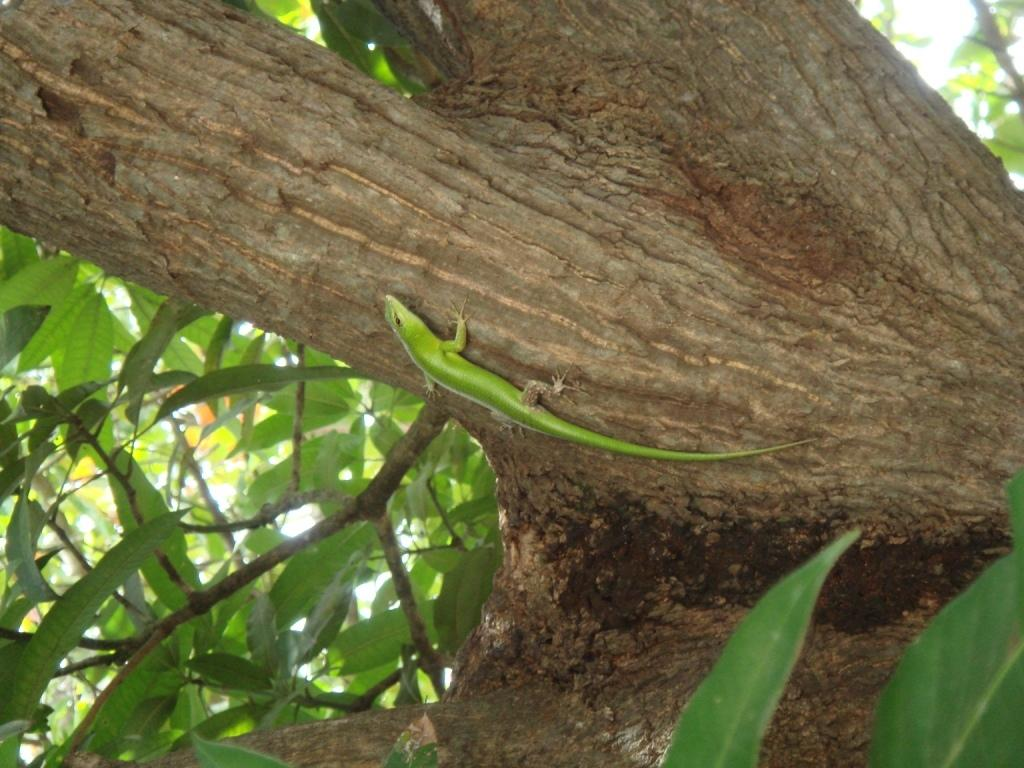What is the main object in the image? There is a tree in the image. Is there any living creature on the tree? Yes, there is a lizard on the tree. What type of addition problem can be solved using the branches of the tree in the image? There is no addition problem or any mathematical elements present in the image. 